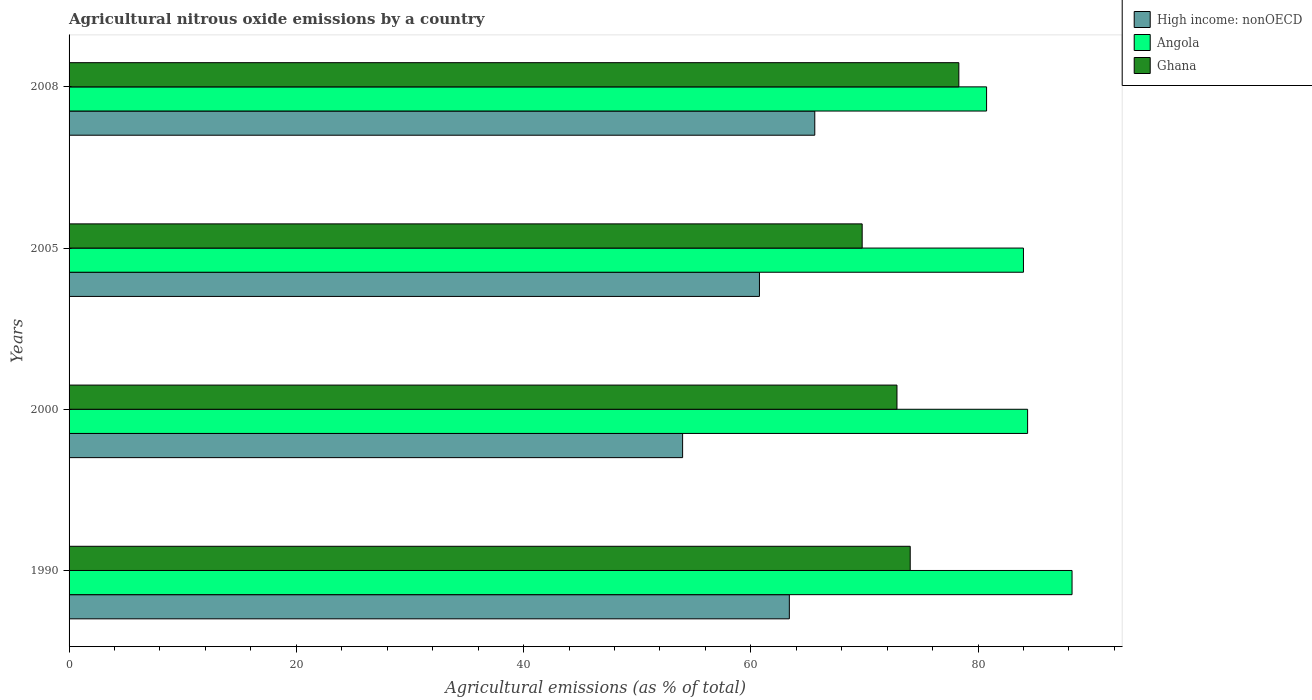Are the number of bars per tick equal to the number of legend labels?
Give a very brief answer. Yes. How many bars are there on the 4th tick from the bottom?
Offer a terse response. 3. What is the label of the 2nd group of bars from the top?
Offer a terse response. 2005. What is the amount of agricultural nitrous oxide emitted in High income: nonOECD in 2005?
Your response must be concise. 60.76. Across all years, what is the maximum amount of agricultural nitrous oxide emitted in Angola?
Ensure brevity in your answer.  88.27. Across all years, what is the minimum amount of agricultural nitrous oxide emitted in Angola?
Your response must be concise. 80.75. What is the total amount of agricultural nitrous oxide emitted in High income: nonOECD in the graph?
Ensure brevity in your answer.  243.77. What is the difference between the amount of agricultural nitrous oxide emitted in High income: nonOECD in 1990 and that in 2000?
Make the answer very short. 9.39. What is the difference between the amount of agricultural nitrous oxide emitted in Angola in 1990 and the amount of agricultural nitrous oxide emitted in Ghana in 2005?
Ensure brevity in your answer.  18.47. What is the average amount of agricultural nitrous oxide emitted in Angola per year?
Offer a terse response. 84.34. In the year 1990, what is the difference between the amount of agricultural nitrous oxide emitted in Angola and amount of agricultural nitrous oxide emitted in High income: nonOECD?
Provide a succinct answer. 24.88. In how many years, is the amount of agricultural nitrous oxide emitted in Angola greater than 48 %?
Make the answer very short. 4. What is the ratio of the amount of agricultural nitrous oxide emitted in Ghana in 2005 to that in 2008?
Offer a very short reply. 0.89. Is the amount of agricultural nitrous oxide emitted in Angola in 1990 less than that in 2008?
Give a very brief answer. No. What is the difference between the highest and the second highest amount of agricultural nitrous oxide emitted in Ghana?
Provide a short and direct response. 4.28. What is the difference between the highest and the lowest amount of agricultural nitrous oxide emitted in High income: nonOECD?
Offer a terse response. 11.63. In how many years, is the amount of agricultural nitrous oxide emitted in Angola greater than the average amount of agricultural nitrous oxide emitted in Angola taken over all years?
Offer a terse response. 2. What does the 2nd bar from the top in 2008 represents?
Your answer should be very brief. Angola. What does the 1st bar from the bottom in 2008 represents?
Make the answer very short. High income: nonOECD. Is it the case that in every year, the sum of the amount of agricultural nitrous oxide emitted in Angola and amount of agricultural nitrous oxide emitted in Ghana is greater than the amount of agricultural nitrous oxide emitted in High income: nonOECD?
Ensure brevity in your answer.  Yes. How many bars are there?
Keep it short and to the point. 12. Does the graph contain any zero values?
Your answer should be very brief. No. Where does the legend appear in the graph?
Your answer should be very brief. Top right. What is the title of the graph?
Make the answer very short. Agricultural nitrous oxide emissions by a country. Does "Latin America(all income levels)" appear as one of the legend labels in the graph?
Offer a very short reply. No. What is the label or title of the X-axis?
Provide a succinct answer. Agricultural emissions (as % of total). What is the label or title of the Y-axis?
Provide a succinct answer. Years. What is the Agricultural emissions (as % of total) in High income: nonOECD in 1990?
Offer a terse response. 63.39. What is the Agricultural emissions (as % of total) in Angola in 1990?
Offer a very short reply. 88.27. What is the Agricultural emissions (as % of total) in Ghana in 1990?
Give a very brief answer. 74.03. What is the Agricultural emissions (as % of total) of High income: nonOECD in 2000?
Provide a short and direct response. 54. What is the Agricultural emissions (as % of total) in Angola in 2000?
Ensure brevity in your answer.  84.36. What is the Agricultural emissions (as % of total) of Ghana in 2000?
Give a very brief answer. 72.86. What is the Agricultural emissions (as % of total) in High income: nonOECD in 2005?
Your response must be concise. 60.76. What is the Agricultural emissions (as % of total) of Angola in 2005?
Offer a very short reply. 83.99. What is the Agricultural emissions (as % of total) of Ghana in 2005?
Offer a terse response. 69.8. What is the Agricultural emissions (as % of total) in High income: nonOECD in 2008?
Offer a very short reply. 65.63. What is the Agricultural emissions (as % of total) in Angola in 2008?
Make the answer very short. 80.75. What is the Agricultural emissions (as % of total) of Ghana in 2008?
Offer a terse response. 78.31. Across all years, what is the maximum Agricultural emissions (as % of total) in High income: nonOECD?
Your answer should be compact. 65.63. Across all years, what is the maximum Agricultural emissions (as % of total) in Angola?
Make the answer very short. 88.27. Across all years, what is the maximum Agricultural emissions (as % of total) of Ghana?
Provide a succinct answer. 78.31. Across all years, what is the minimum Agricultural emissions (as % of total) of High income: nonOECD?
Provide a short and direct response. 54. Across all years, what is the minimum Agricultural emissions (as % of total) in Angola?
Your answer should be very brief. 80.75. Across all years, what is the minimum Agricultural emissions (as % of total) in Ghana?
Provide a short and direct response. 69.8. What is the total Agricultural emissions (as % of total) in High income: nonOECD in the graph?
Ensure brevity in your answer.  243.77. What is the total Agricultural emissions (as % of total) of Angola in the graph?
Your answer should be very brief. 337.37. What is the total Agricultural emissions (as % of total) of Ghana in the graph?
Keep it short and to the point. 294.99. What is the difference between the Agricultural emissions (as % of total) in High income: nonOECD in 1990 and that in 2000?
Offer a very short reply. 9.39. What is the difference between the Agricultural emissions (as % of total) of Angola in 1990 and that in 2000?
Ensure brevity in your answer.  3.91. What is the difference between the Agricultural emissions (as % of total) of Ghana in 1990 and that in 2000?
Your response must be concise. 1.17. What is the difference between the Agricultural emissions (as % of total) of High income: nonOECD in 1990 and that in 2005?
Your answer should be compact. 2.63. What is the difference between the Agricultural emissions (as % of total) of Angola in 1990 and that in 2005?
Your answer should be compact. 4.28. What is the difference between the Agricultural emissions (as % of total) of Ghana in 1990 and that in 2005?
Your answer should be compact. 4.23. What is the difference between the Agricultural emissions (as % of total) in High income: nonOECD in 1990 and that in 2008?
Provide a succinct answer. -2.24. What is the difference between the Agricultural emissions (as % of total) of Angola in 1990 and that in 2008?
Make the answer very short. 7.52. What is the difference between the Agricultural emissions (as % of total) in Ghana in 1990 and that in 2008?
Make the answer very short. -4.28. What is the difference between the Agricultural emissions (as % of total) of High income: nonOECD in 2000 and that in 2005?
Provide a short and direct response. -6.76. What is the difference between the Agricultural emissions (as % of total) in Angola in 2000 and that in 2005?
Ensure brevity in your answer.  0.37. What is the difference between the Agricultural emissions (as % of total) in Ghana in 2000 and that in 2005?
Ensure brevity in your answer.  3.06. What is the difference between the Agricultural emissions (as % of total) in High income: nonOECD in 2000 and that in 2008?
Ensure brevity in your answer.  -11.63. What is the difference between the Agricultural emissions (as % of total) in Angola in 2000 and that in 2008?
Your answer should be very brief. 3.61. What is the difference between the Agricultural emissions (as % of total) in Ghana in 2000 and that in 2008?
Make the answer very short. -5.45. What is the difference between the Agricultural emissions (as % of total) of High income: nonOECD in 2005 and that in 2008?
Make the answer very short. -4.87. What is the difference between the Agricultural emissions (as % of total) of Angola in 2005 and that in 2008?
Ensure brevity in your answer.  3.25. What is the difference between the Agricultural emissions (as % of total) in Ghana in 2005 and that in 2008?
Offer a terse response. -8.51. What is the difference between the Agricultural emissions (as % of total) in High income: nonOECD in 1990 and the Agricultural emissions (as % of total) in Angola in 2000?
Your answer should be very brief. -20.97. What is the difference between the Agricultural emissions (as % of total) in High income: nonOECD in 1990 and the Agricultural emissions (as % of total) in Ghana in 2000?
Keep it short and to the point. -9.47. What is the difference between the Agricultural emissions (as % of total) of Angola in 1990 and the Agricultural emissions (as % of total) of Ghana in 2000?
Offer a terse response. 15.41. What is the difference between the Agricultural emissions (as % of total) in High income: nonOECD in 1990 and the Agricultural emissions (as % of total) in Angola in 2005?
Your answer should be compact. -20.6. What is the difference between the Agricultural emissions (as % of total) in High income: nonOECD in 1990 and the Agricultural emissions (as % of total) in Ghana in 2005?
Make the answer very short. -6.41. What is the difference between the Agricultural emissions (as % of total) of Angola in 1990 and the Agricultural emissions (as % of total) of Ghana in 2005?
Your answer should be compact. 18.47. What is the difference between the Agricultural emissions (as % of total) in High income: nonOECD in 1990 and the Agricultural emissions (as % of total) in Angola in 2008?
Give a very brief answer. -17.36. What is the difference between the Agricultural emissions (as % of total) in High income: nonOECD in 1990 and the Agricultural emissions (as % of total) in Ghana in 2008?
Provide a succinct answer. -14.92. What is the difference between the Agricultural emissions (as % of total) in Angola in 1990 and the Agricultural emissions (as % of total) in Ghana in 2008?
Your response must be concise. 9.96. What is the difference between the Agricultural emissions (as % of total) of High income: nonOECD in 2000 and the Agricultural emissions (as % of total) of Angola in 2005?
Your answer should be very brief. -30. What is the difference between the Agricultural emissions (as % of total) of High income: nonOECD in 2000 and the Agricultural emissions (as % of total) of Ghana in 2005?
Provide a short and direct response. -15.8. What is the difference between the Agricultural emissions (as % of total) of Angola in 2000 and the Agricultural emissions (as % of total) of Ghana in 2005?
Offer a very short reply. 14.56. What is the difference between the Agricultural emissions (as % of total) of High income: nonOECD in 2000 and the Agricultural emissions (as % of total) of Angola in 2008?
Your answer should be very brief. -26.75. What is the difference between the Agricultural emissions (as % of total) of High income: nonOECD in 2000 and the Agricultural emissions (as % of total) of Ghana in 2008?
Provide a succinct answer. -24.31. What is the difference between the Agricultural emissions (as % of total) of Angola in 2000 and the Agricultural emissions (as % of total) of Ghana in 2008?
Your answer should be very brief. 6.05. What is the difference between the Agricultural emissions (as % of total) in High income: nonOECD in 2005 and the Agricultural emissions (as % of total) in Angola in 2008?
Offer a terse response. -19.99. What is the difference between the Agricultural emissions (as % of total) of High income: nonOECD in 2005 and the Agricultural emissions (as % of total) of Ghana in 2008?
Keep it short and to the point. -17.55. What is the difference between the Agricultural emissions (as % of total) of Angola in 2005 and the Agricultural emissions (as % of total) of Ghana in 2008?
Your answer should be very brief. 5.69. What is the average Agricultural emissions (as % of total) in High income: nonOECD per year?
Your response must be concise. 60.94. What is the average Agricultural emissions (as % of total) in Angola per year?
Offer a terse response. 84.34. What is the average Agricultural emissions (as % of total) of Ghana per year?
Offer a terse response. 73.75. In the year 1990, what is the difference between the Agricultural emissions (as % of total) of High income: nonOECD and Agricultural emissions (as % of total) of Angola?
Give a very brief answer. -24.88. In the year 1990, what is the difference between the Agricultural emissions (as % of total) of High income: nonOECD and Agricultural emissions (as % of total) of Ghana?
Give a very brief answer. -10.64. In the year 1990, what is the difference between the Agricultural emissions (as % of total) of Angola and Agricultural emissions (as % of total) of Ghana?
Provide a short and direct response. 14.24. In the year 2000, what is the difference between the Agricultural emissions (as % of total) in High income: nonOECD and Agricultural emissions (as % of total) in Angola?
Your answer should be very brief. -30.36. In the year 2000, what is the difference between the Agricultural emissions (as % of total) in High income: nonOECD and Agricultural emissions (as % of total) in Ghana?
Provide a short and direct response. -18.87. In the year 2000, what is the difference between the Agricultural emissions (as % of total) of Angola and Agricultural emissions (as % of total) of Ghana?
Your response must be concise. 11.5. In the year 2005, what is the difference between the Agricultural emissions (as % of total) of High income: nonOECD and Agricultural emissions (as % of total) of Angola?
Make the answer very short. -23.23. In the year 2005, what is the difference between the Agricultural emissions (as % of total) of High income: nonOECD and Agricultural emissions (as % of total) of Ghana?
Your answer should be very brief. -9.04. In the year 2005, what is the difference between the Agricultural emissions (as % of total) of Angola and Agricultural emissions (as % of total) of Ghana?
Provide a succinct answer. 14.19. In the year 2008, what is the difference between the Agricultural emissions (as % of total) of High income: nonOECD and Agricultural emissions (as % of total) of Angola?
Make the answer very short. -15.12. In the year 2008, what is the difference between the Agricultural emissions (as % of total) in High income: nonOECD and Agricultural emissions (as % of total) in Ghana?
Your answer should be very brief. -12.68. In the year 2008, what is the difference between the Agricultural emissions (as % of total) in Angola and Agricultural emissions (as % of total) in Ghana?
Your answer should be compact. 2.44. What is the ratio of the Agricultural emissions (as % of total) in High income: nonOECD in 1990 to that in 2000?
Your response must be concise. 1.17. What is the ratio of the Agricultural emissions (as % of total) of Angola in 1990 to that in 2000?
Your answer should be very brief. 1.05. What is the ratio of the Agricultural emissions (as % of total) of High income: nonOECD in 1990 to that in 2005?
Give a very brief answer. 1.04. What is the ratio of the Agricultural emissions (as % of total) in Angola in 1990 to that in 2005?
Offer a terse response. 1.05. What is the ratio of the Agricultural emissions (as % of total) of Ghana in 1990 to that in 2005?
Provide a short and direct response. 1.06. What is the ratio of the Agricultural emissions (as % of total) in High income: nonOECD in 1990 to that in 2008?
Give a very brief answer. 0.97. What is the ratio of the Agricultural emissions (as % of total) of Angola in 1990 to that in 2008?
Offer a very short reply. 1.09. What is the ratio of the Agricultural emissions (as % of total) of Ghana in 1990 to that in 2008?
Make the answer very short. 0.95. What is the ratio of the Agricultural emissions (as % of total) of High income: nonOECD in 2000 to that in 2005?
Ensure brevity in your answer.  0.89. What is the ratio of the Agricultural emissions (as % of total) in Angola in 2000 to that in 2005?
Give a very brief answer. 1. What is the ratio of the Agricultural emissions (as % of total) in Ghana in 2000 to that in 2005?
Make the answer very short. 1.04. What is the ratio of the Agricultural emissions (as % of total) of High income: nonOECD in 2000 to that in 2008?
Provide a short and direct response. 0.82. What is the ratio of the Agricultural emissions (as % of total) in Angola in 2000 to that in 2008?
Make the answer very short. 1.04. What is the ratio of the Agricultural emissions (as % of total) in Ghana in 2000 to that in 2008?
Your response must be concise. 0.93. What is the ratio of the Agricultural emissions (as % of total) of High income: nonOECD in 2005 to that in 2008?
Give a very brief answer. 0.93. What is the ratio of the Agricultural emissions (as % of total) of Angola in 2005 to that in 2008?
Ensure brevity in your answer.  1.04. What is the ratio of the Agricultural emissions (as % of total) in Ghana in 2005 to that in 2008?
Ensure brevity in your answer.  0.89. What is the difference between the highest and the second highest Agricultural emissions (as % of total) in High income: nonOECD?
Provide a succinct answer. 2.24. What is the difference between the highest and the second highest Agricultural emissions (as % of total) of Angola?
Ensure brevity in your answer.  3.91. What is the difference between the highest and the second highest Agricultural emissions (as % of total) of Ghana?
Offer a terse response. 4.28. What is the difference between the highest and the lowest Agricultural emissions (as % of total) in High income: nonOECD?
Ensure brevity in your answer.  11.63. What is the difference between the highest and the lowest Agricultural emissions (as % of total) of Angola?
Your response must be concise. 7.52. What is the difference between the highest and the lowest Agricultural emissions (as % of total) in Ghana?
Provide a short and direct response. 8.51. 